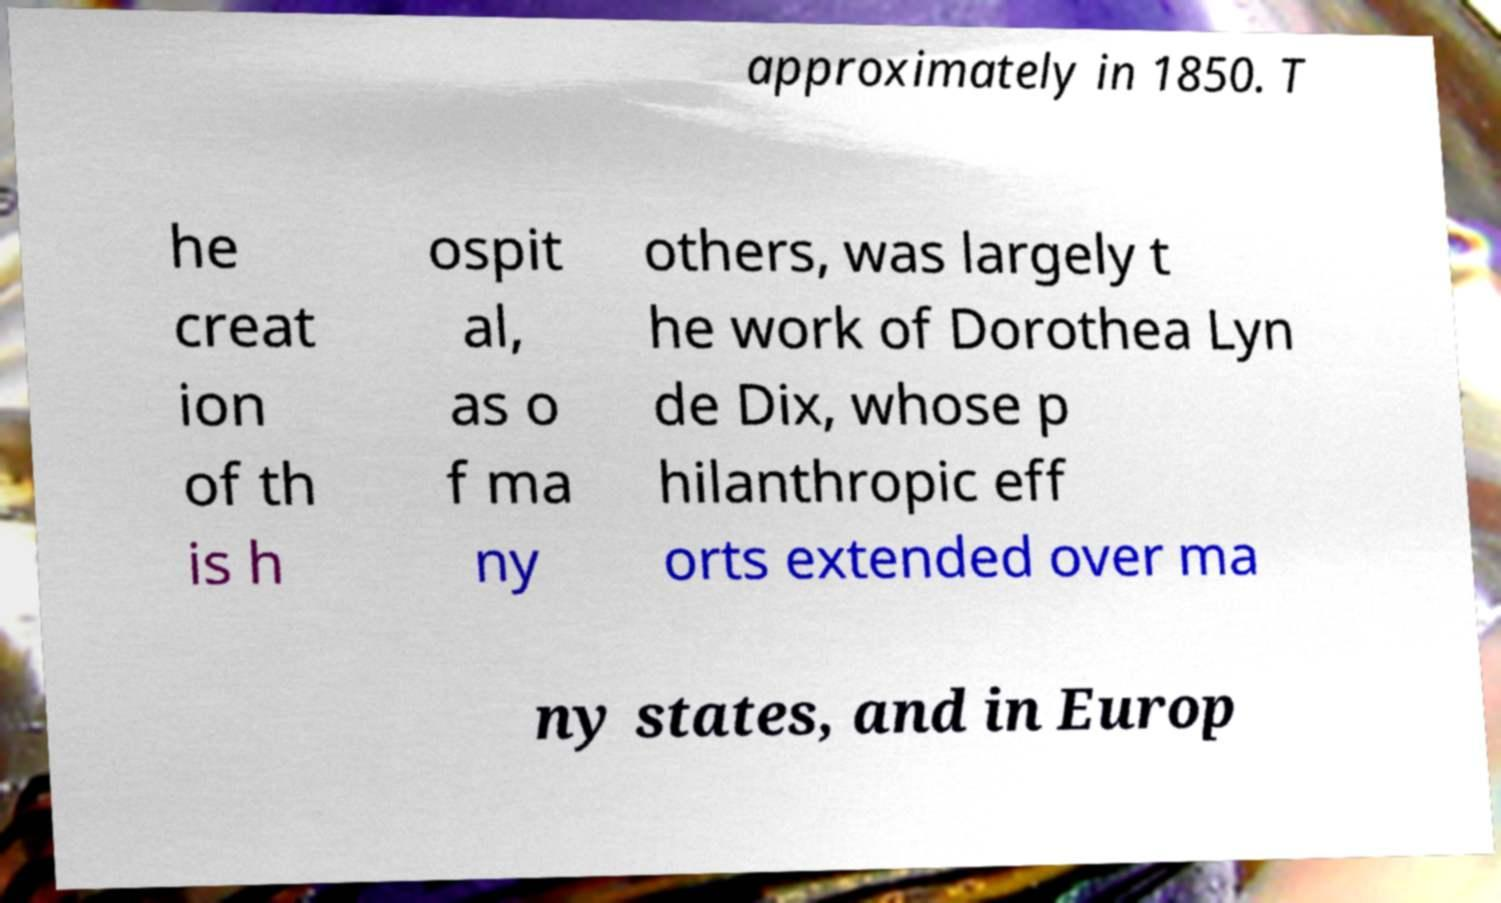Please identify and transcribe the text found in this image. approximately in 1850. T he creat ion of th is h ospit al, as o f ma ny others, was largely t he work of Dorothea Lyn de Dix, whose p hilanthropic eff orts extended over ma ny states, and in Europ 